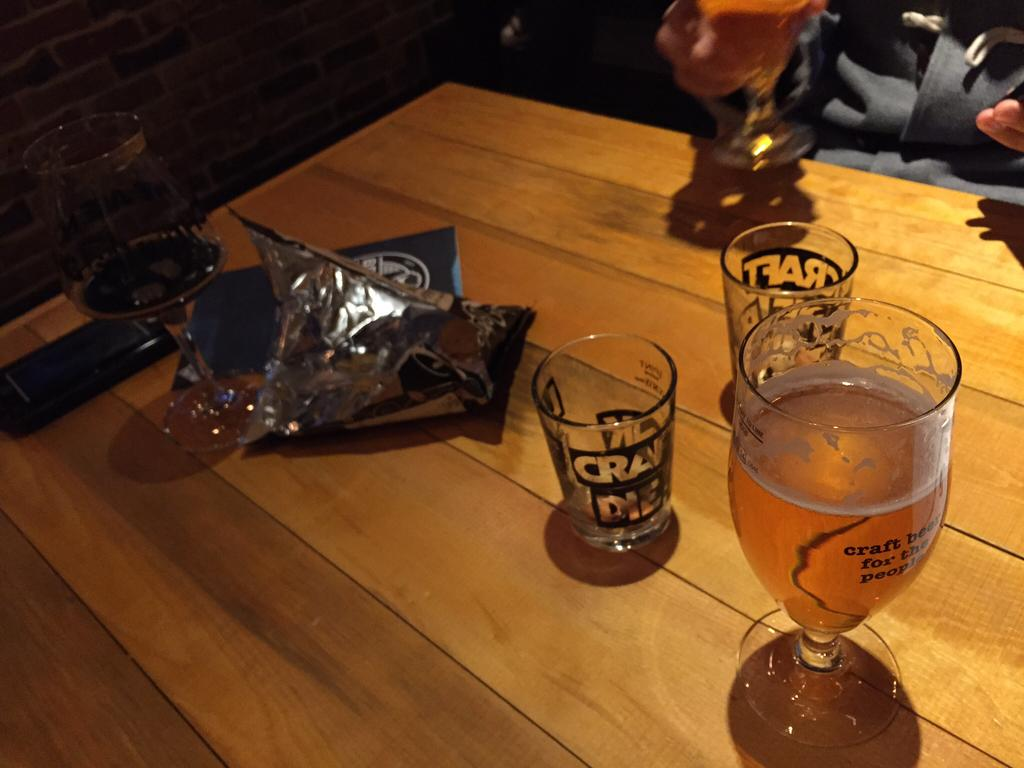What piece of furniture is present in the image? There is a table in the image. What is on the table? There is a glass of wine and empty glasses on the table. Can you describe the person in the image? There is a person in the right top corner of the image. What type of apparel is the snake wearing in the image? There is no snake present in the image, so it cannot be wearing any apparel. 